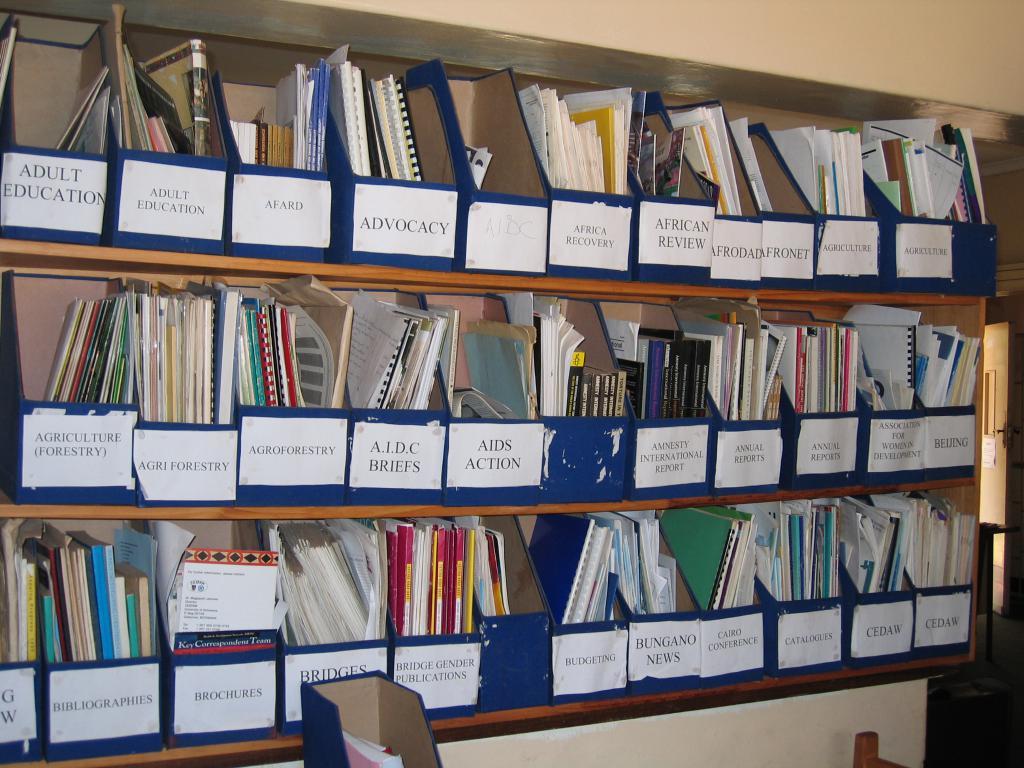What is the top left label say?
Provide a short and direct response. Adult education. What is the bottom right label say?
Make the answer very short. Cedaw. 